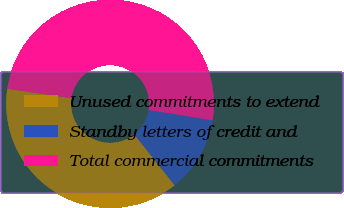Convert chart to OTSL. <chart><loc_0><loc_0><loc_500><loc_500><pie_chart><fcel>Unused commitments to extend<fcel>Standby letters of credit and<fcel>Total commercial commitments<nl><fcel>38.0%<fcel>11.8%<fcel>50.2%<nl></chart> 